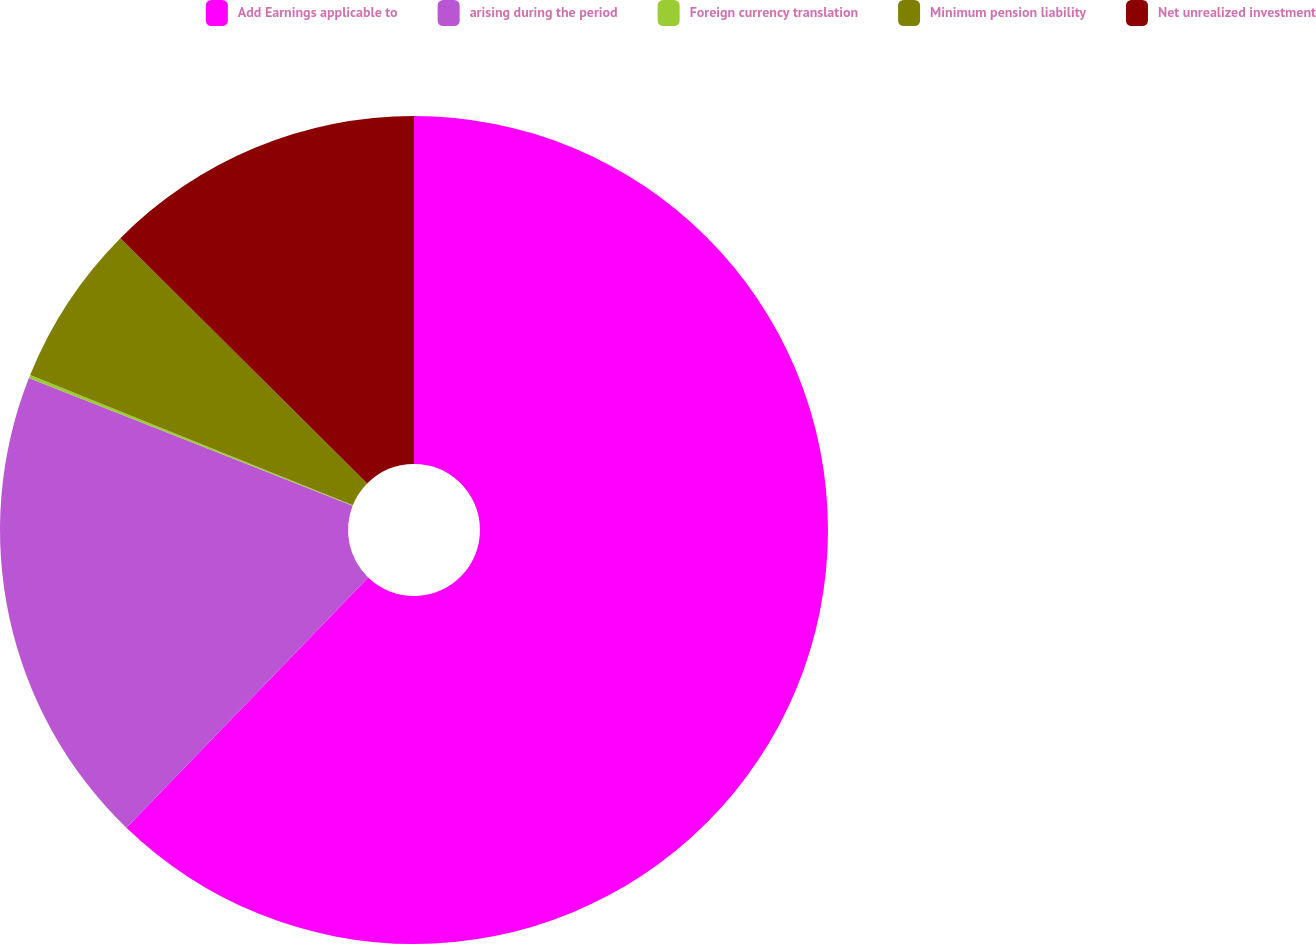Convert chart. <chart><loc_0><loc_0><loc_500><loc_500><pie_chart><fcel>Add Earnings applicable to<fcel>arising during the period<fcel>Foreign currency translation<fcel>Minimum pension liability<fcel>Net unrealized investment<nl><fcel>62.23%<fcel>18.76%<fcel>0.13%<fcel>6.34%<fcel>12.55%<nl></chart> 